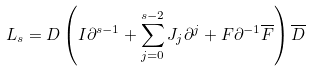Convert formula to latex. <formula><loc_0><loc_0><loc_500><loc_500>L _ { s } = D \left ( I \partial ^ { s - 1 } + \sum _ { j = 0 } ^ { s - 2 } J _ { j } \partial ^ { j } + F \partial ^ { - 1 } { \overline { F } } \right ) { \overline { D } }</formula> 